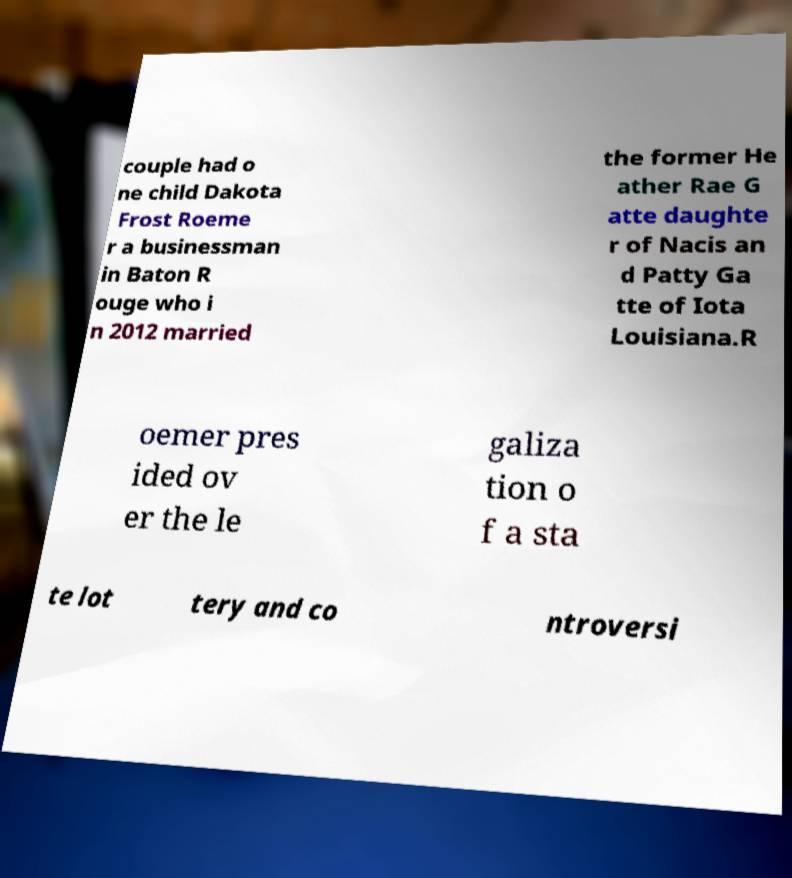Please read and relay the text visible in this image. What does it say? couple had o ne child Dakota Frost Roeme r a businessman in Baton R ouge who i n 2012 married the former He ather Rae G atte daughte r of Nacis an d Patty Ga tte of Iota Louisiana.R oemer pres ided ov er the le galiza tion o f a sta te lot tery and co ntroversi 